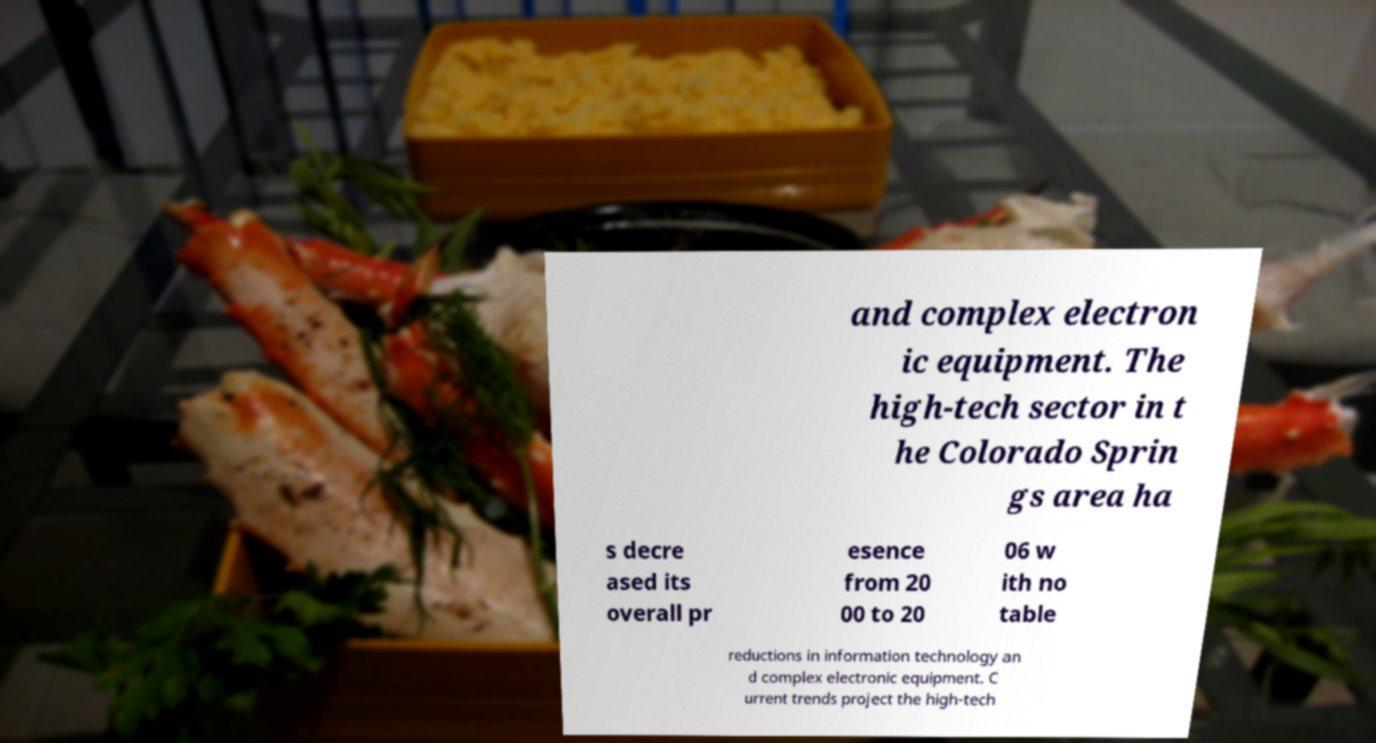Please identify and transcribe the text found in this image. and complex electron ic equipment. The high-tech sector in t he Colorado Sprin gs area ha s decre ased its overall pr esence from 20 00 to 20 06 w ith no table reductions in information technology an d complex electronic equipment. C urrent trends project the high-tech 